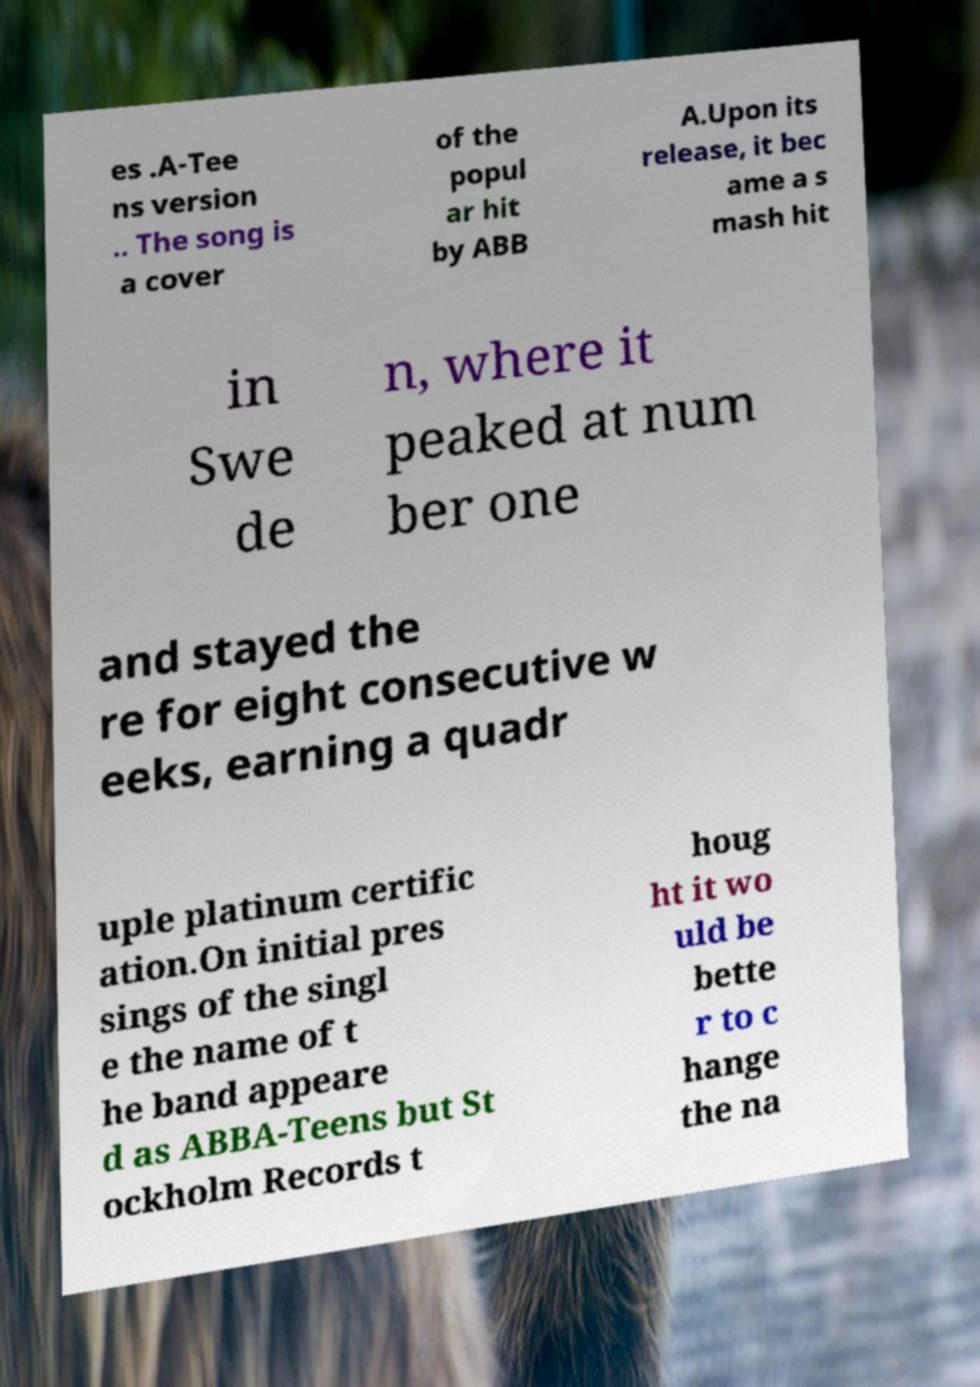I need the written content from this picture converted into text. Can you do that? es .A-Tee ns version .. The song is a cover of the popul ar hit by ABB A.Upon its release, it bec ame a s mash hit in Swe de n, where it peaked at num ber one and stayed the re for eight consecutive w eeks, earning a quadr uple platinum certific ation.On initial pres sings of the singl e the name of t he band appeare d as ABBA-Teens but St ockholm Records t houg ht it wo uld be bette r to c hange the na 